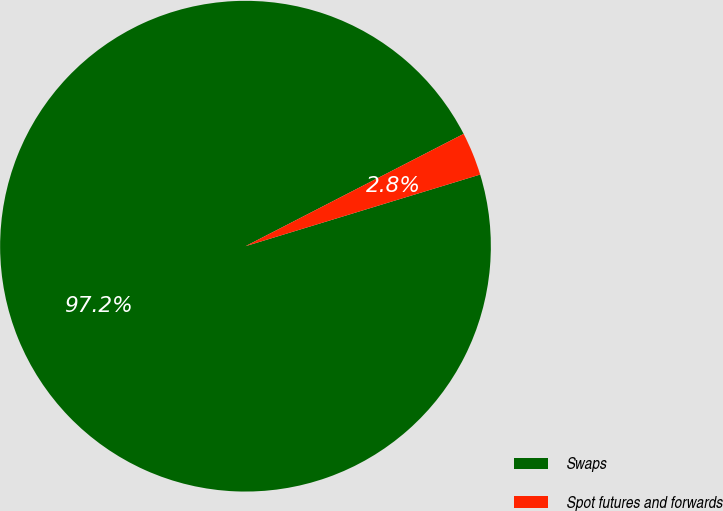<chart> <loc_0><loc_0><loc_500><loc_500><pie_chart><fcel>Swaps<fcel>Spot futures and forwards<nl><fcel>97.15%<fcel>2.85%<nl></chart> 